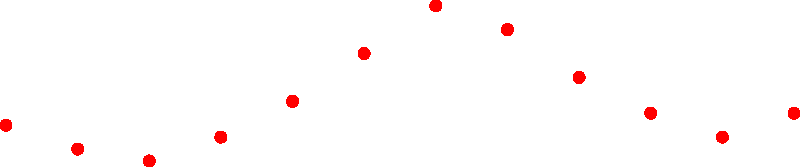Based on the polar plot showing monthly donations to your nonprofit organization, which month experiences the highest influx of donations, and what strategy could you implement to capitalize on this peak period? To answer this question, we need to analyze the polar plot step-by-step:

1. Understand the plot: The radial distance represents the donation amount in thousands of dollars, while the angular position represents the months of the year.

2. Identify the peak: The highest point on the plot occurs around the 180-degree mark, which corresponds to July.

3. Analyze the pattern: We can see that donations start increasing from May (150 degrees), peak in July (180 degrees), and then gradually decrease until December (330 degrees).

4. Determine the strategy: To capitalize on this peak period, the nonprofit could:
   a) Launch a major fundraising campaign in June to build momentum for July.
   b) Increase marketing efforts and donor outreach in May and June.
   c) Plan signature events or challenges for July to maximize donation potential.
   d) Create a sense of urgency by setting time-limited matching gift opportunities during the peak month.

5. Consider the overall cycle: While focusing on the peak is important, it's also crucial to develop strategies for maintaining donor engagement during lower periods, such as January to April.

The highest influx of donations occurs in July, and a strategy to capitalize on this would be to launch a major fundraising campaign in June, building up to a series of high-impact events and matching gift opportunities in July.
Answer: July; Launch major campaign in June, peaking with high-impact events and matching gifts in July. 